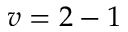<formula> <loc_0><loc_0><loc_500><loc_500>v = 2 - 1</formula> 